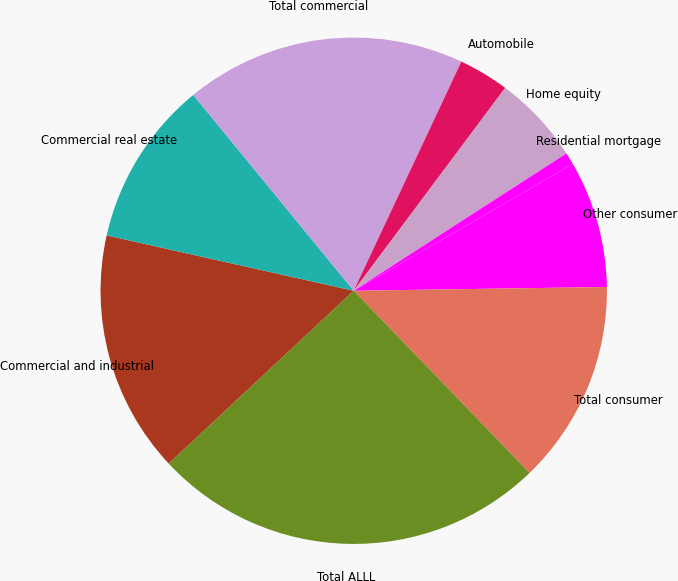<chart> <loc_0><loc_0><loc_500><loc_500><pie_chart><fcel>Commercial and industrial<fcel>Commercial real estate<fcel>Total commercial<fcel>Automobile<fcel>Home equity<fcel>Residential mortgage<fcel>Other consumer<fcel>Total consumer<fcel>Total ALLL<nl><fcel>15.47%<fcel>10.57%<fcel>17.92%<fcel>3.22%<fcel>5.67%<fcel>0.77%<fcel>8.12%<fcel>13.02%<fcel>25.27%<nl></chart> 